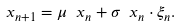<formula> <loc_0><loc_0><loc_500><loc_500>\ x _ { n + 1 } = \mu \ x _ { n } + \sigma \ x _ { n } \cdot \xi _ { n } .</formula> 